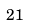Convert formula to latex. <formula><loc_0><loc_0><loc_500><loc_500>2 1</formula> 